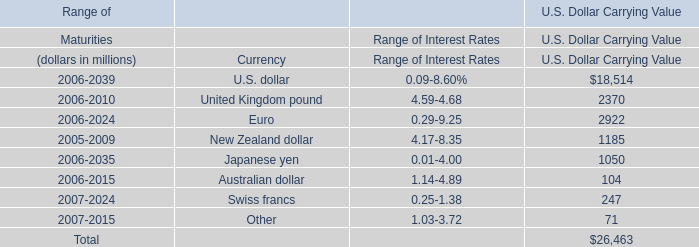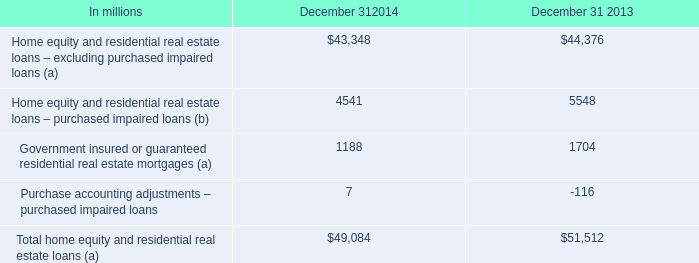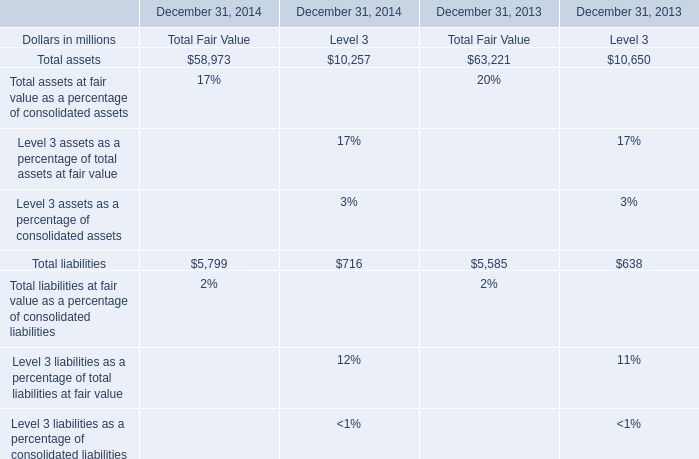What is the difference between 2013 and 2014 's highest Total assets for Total Fair Value? 
Computations: (63221 - 58973)
Answer: 4248.0. 